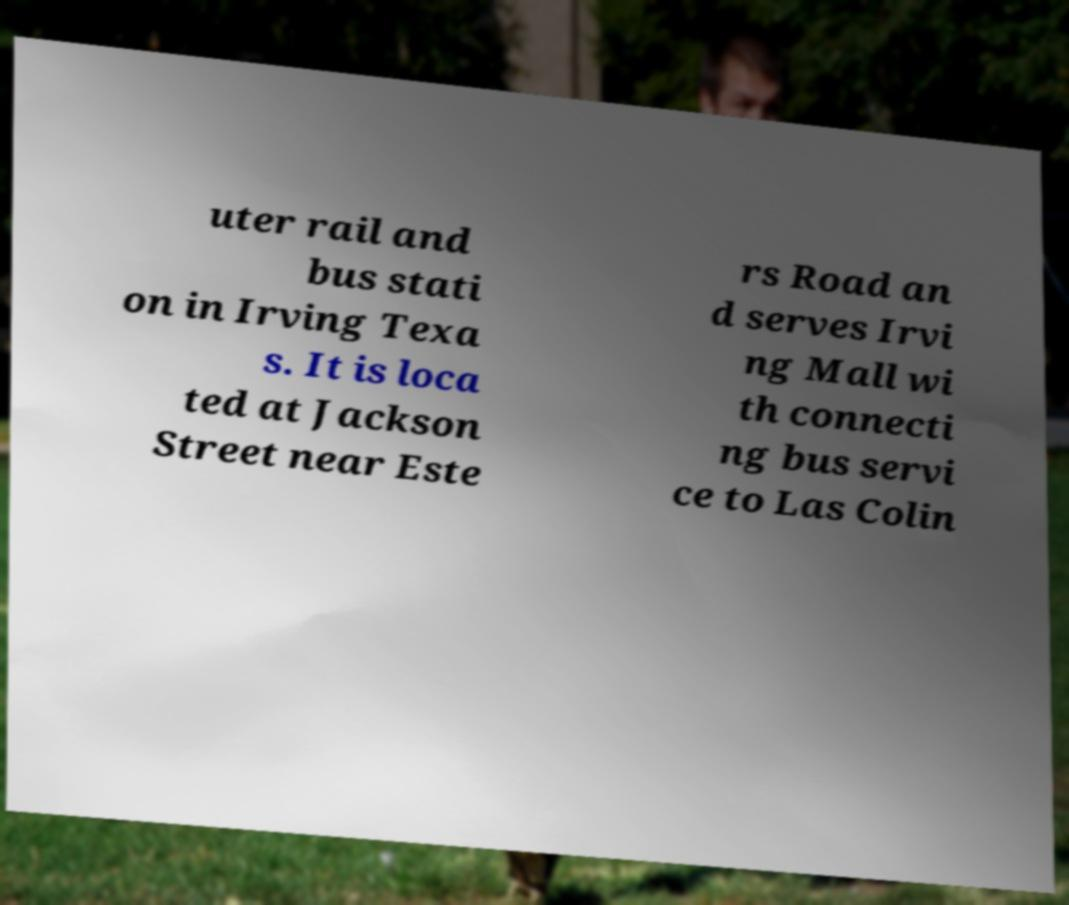Could you assist in decoding the text presented in this image and type it out clearly? uter rail and bus stati on in Irving Texa s. It is loca ted at Jackson Street near Este rs Road an d serves Irvi ng Mall wi th connecti ng bus servi ce to Las Colin 